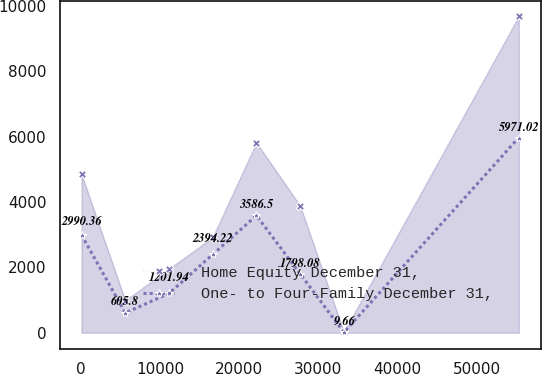Convert chart to OTSL. <chart><loc_0><loc_0><loc_500><loc_500><line_chart><ecel><fcel>Home Equity December 31,<fcel>One- to Four-Family December 31,<nl><fcel>74.11<fcel>4847<fcel>2990.36<nl><fcel>5601.72<fcel>983.04<fcel>605.8<nl><fcel>11129.3<fcel>1949.03<fcel>1201.94<nl><fcel>16656.9<fcel>2915.02<fcel>2394.22<nl><fcel>22184.5<fcel>5812.99<fcel>3586.5<nl><fcel>27712.2<fcel>3881.01<fcel>1798.08<nl><fcel>33239.8<fcel>17.05<fcel>9.66<nl><fcel>55350.2<fcel>9676.9<fcel>5971.02<nl></chart> 